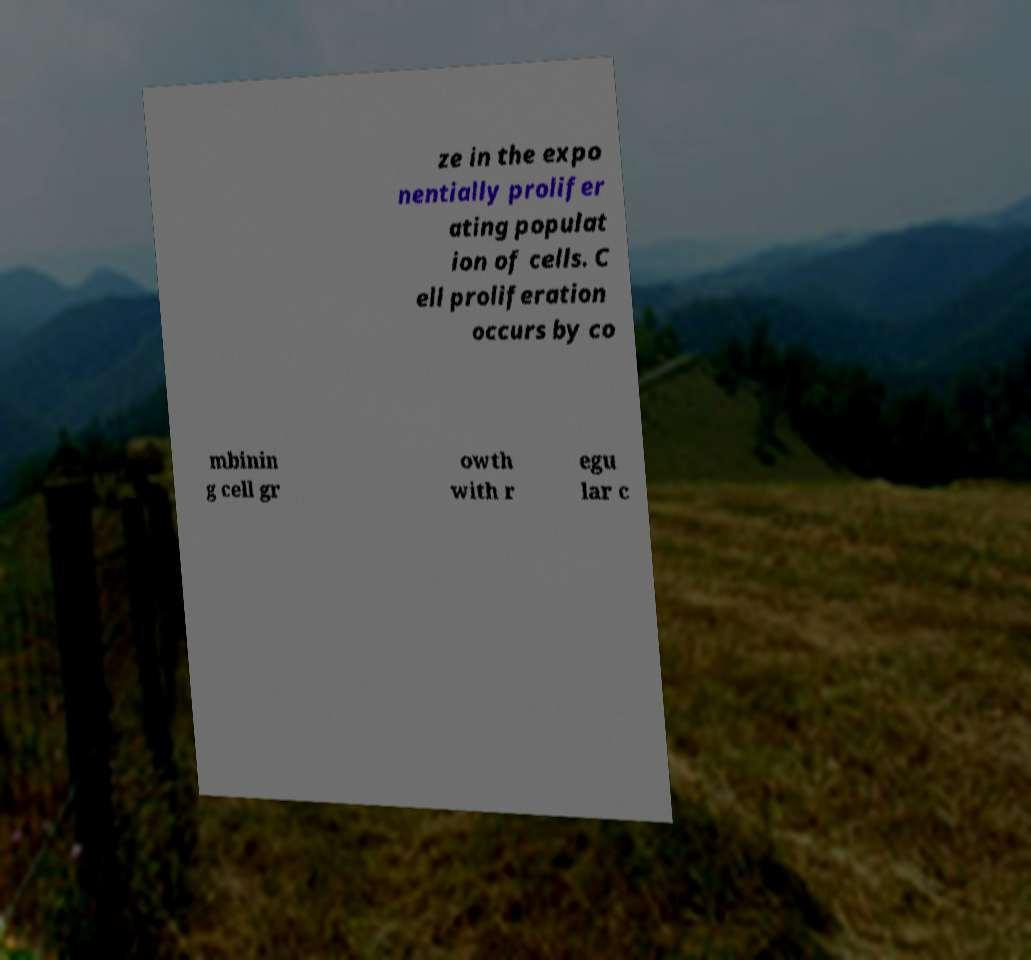Can you read and provide the text displayed in the image?This photo seems to have some interesting text. Can you extract and type it out for me? ze in the expo nentially prolifer ating populat ion of cells. C ell proliferation occurs by co mbinin g cell gr owth with r egu lar c 